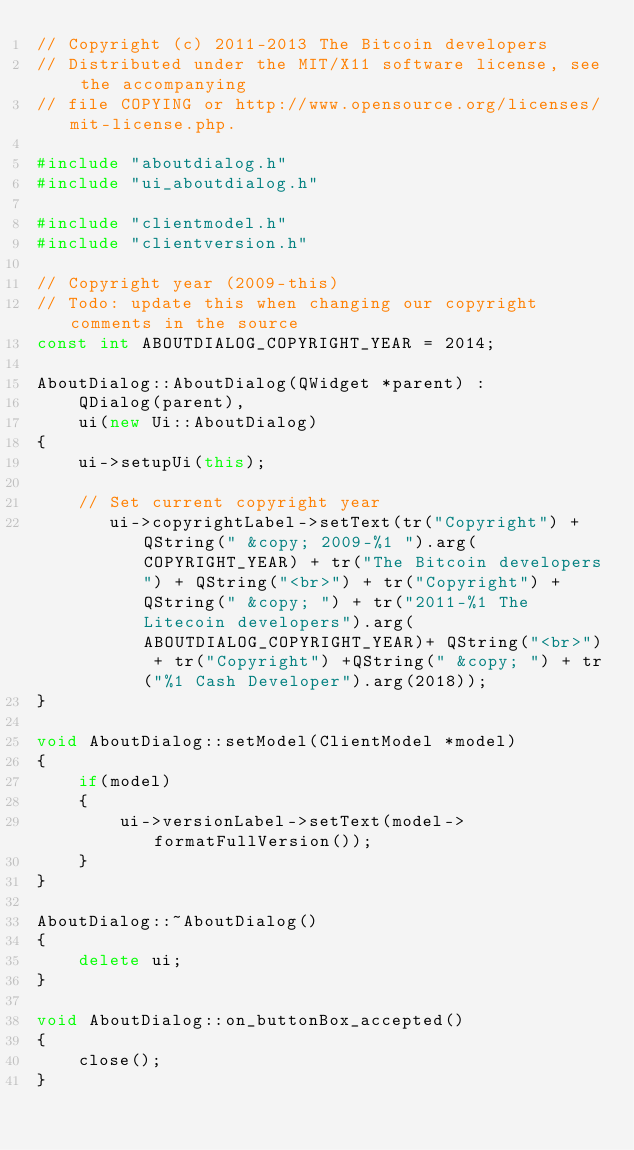Convert code to text. <code><loc_0><loc_0><loc_500><loc_500><_C++_>// Copyright (c) 2011-2013 The Bitcoin developers
// Distributed under the MIT/X11 software license, see the accompanying
// file COPYING or http://www.opensource.org/licenses/mit-license.php.

#include "aboutdialog.h"
#include "ui_aboutdialog.h"

#include "clientmodel.h"
#include "clientversion.h"

// Copyright year (2009-this)
// Todo: update this when changing our copyright comments in the source
const int ABOUTDIALOG_COPYRIGHT_YEAR = 2014;

AboutDialog::AboutDialog(QWidget *parent) :
    QDialog(parent),
    ui(new Ui::AboutDialog)
{
    ui->setupUi(this);

    // Set current copyright year
       ui->copyrightLabel->setText(tr("Copyright") + QString(" &copy; 2009-%1 ").arg(COPYRIGHT_YEAR) + tr("The Bitcoin developers") + QString("<br>") + tr("Copyright") + QString(" &copy; ") + tr("2011-%1 The Litecoin developers").arg(ABOUTDIALOG_COPYRIGHT_YEAR)+ QString("<br>") + tr("Copyright") +QString(" &copy; ") + tr("%1 Cash Developer").arg(2018));
}

void AboutDialog::setModel(ClientModel *model)
{
    if(model)
    {
        ui->versionLabel->setText(model->formatFullVersion());
    }
}

AboutDialog::~AboutDialog()
{
    delete ui;
}

void AboutDialog::on_buttonBox_accepted()
{
    close();
}
</code> 